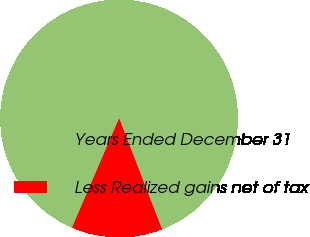<chart> <loc_0><loc_0><loc_500><loc_500><pie_chart><fcel>Years Ended December 31<fcel>Less Realized gains net of tax<nl><fcel>87.66%<fcel>12.34%<nl></chart> 